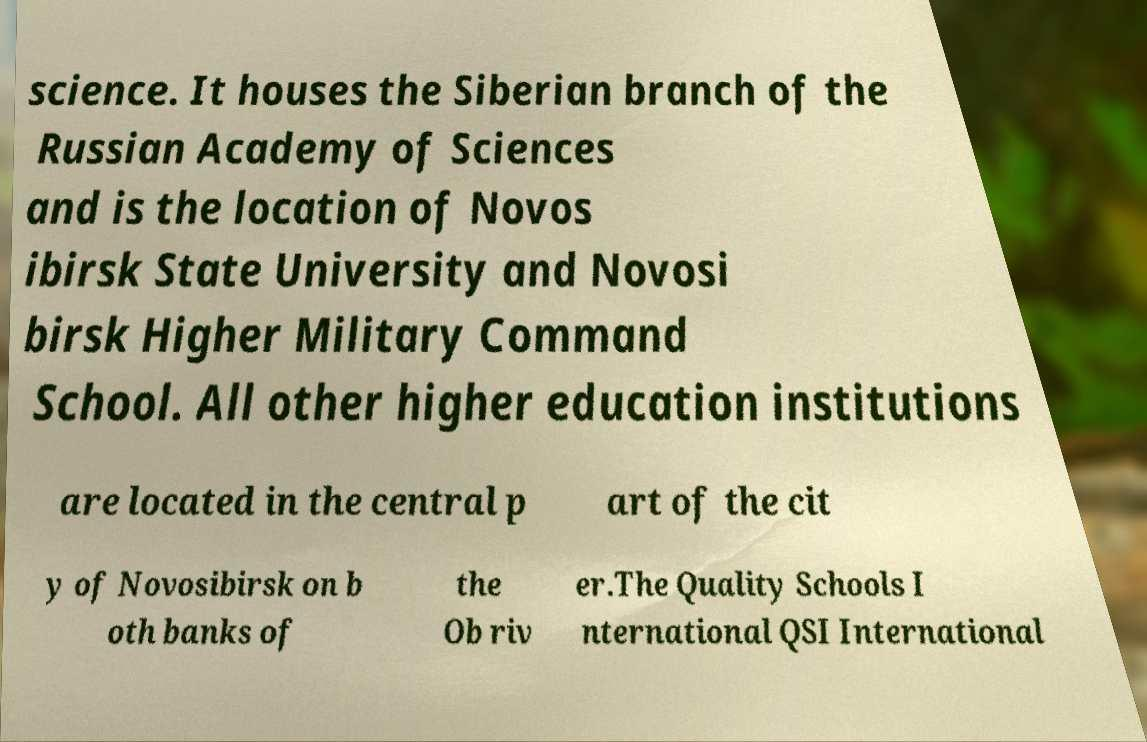What messages or text are displayed in this image? I need them in a readable, typed format. science. It houses the Siberian branch of the Russian Academy of Sciences and is the location of Novos ibirsk State University and Novosi birsk Higher Military Command School. All other higher education institutions are located in the central p art of the cit y of Novosibirsk on b oth banks of the Ob riv er.The Quality Schools I nternational QSI International 